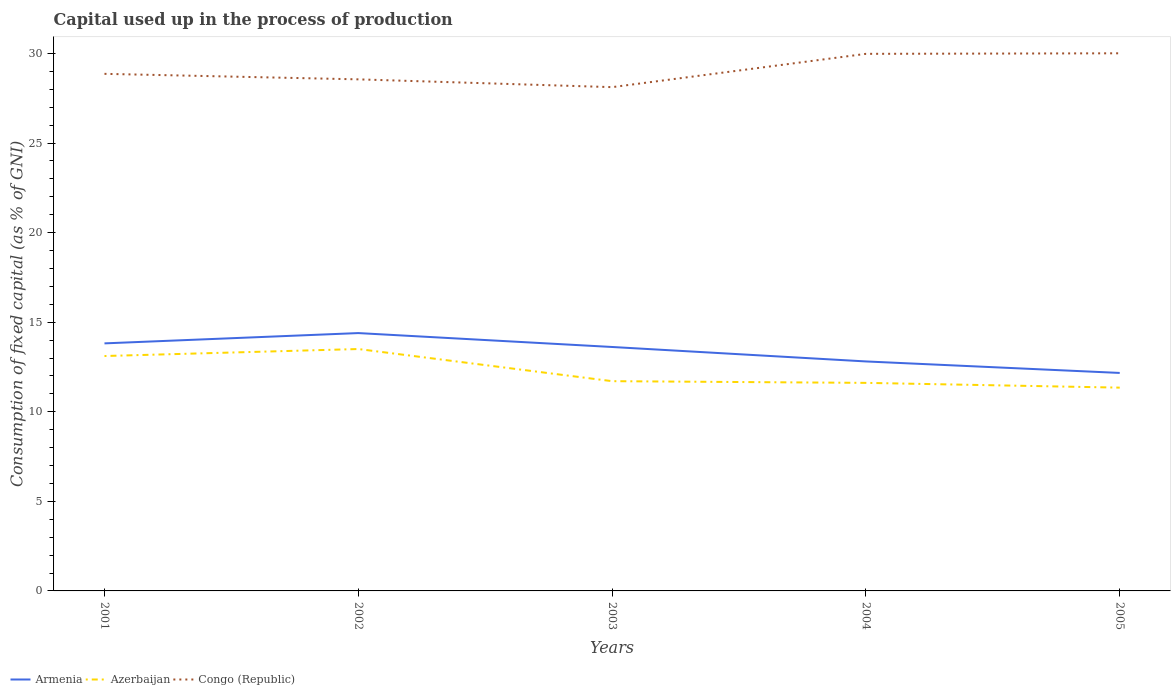How many different coloured lines are there?
Your answer should be very brief. 3. Does the line corresponding to Azerbaijan intersect with the line corresponding to Armenia?
Offer a terse response. No. Is the number of lines equal to the number of legend labels?
Your answer should be very brief. Yes. Across all years, what is the maximum capital used up in the process of production in Azerbaijan?
Provide a short and direct response. 11.35. What is the total capital used up in the process of production in Congo (Republic) in the graph?
Your answer should be very brief. -1.42. What is the difference between the highest and the second highest capital used up in the process of production in Congo (Republic)?
Give a very brief answer. 1.89. How many years are there in the graph?
Give a very brief answer. 5. Where does the legend appear in the graph?
Provide a short and direct response. Bottom left. How many legend labels are there?
Ensure brevity in your answer.  3. How are the legend labels stacked?
Your response must be concise. Horizontal. What is the title of the graph?
Offer a very short reply. Capital used up in the process of production. What is the label or title of the X-axis?
Provide a succinct answer. Years. What is the label or title of the Y-axis?
Ensure brevity in your answer.  Consumption of fixed capital (as % of GNI). What is the Consumption of fixed capital (as % of GNI) of Armenia in 2001?
Offer a terse response. 13.82. What is the Consumption of fixed capital (as % of GNI) in Azerbaijan in 2001?
Give a very brief answer. 13.11. What is the Consumption of fixed capital (as % of GNI) in Congo (Republic) in 2001?
Make the answer very short. 28.86. What is the Consumption of fixed capital (as % of GNI) of Armenia in 2002?
Your answer should be compact. 14.39. What is the Consumption of fixed capital (as % of GNI) in Azerbaijan in 2002?
Offer a terse response. 13.5. What is the Consumption of fixed capital (as % of GNI) of Congo (Republic) in 2002?
Keep it short and to the point. 28.55. What is the Consumption of fixed capital (as % of GNI) in Armenia in 2003?
Your answer should be compact. 13.62. What is the Consumption of fixed capital (as % of GNI) of Azerbaijan in 2003?
Your answer should be very brief. 11.71. What is the Consumption of fixed capital (as % of GNI) in Congo (Republic) in 2003?
Give a very brief answer. 28.12. What is the Consumption of fixed capital (as % of GNI) of Armenia in 2004?
Make the answer very short. 12.81. What is the Consumption of fixed capital (as % of GNI) in Azerbaijan in 2004?
Your response must be concise. 11.61. What is the Consumption of fixed capital (as % of GNI) in Congo (Republic) in 2004?
Your response must be concise. 29.98. What is the Consumption of fixed capital (as % of GNI) of Armenia in 2005?
Make the answer very short. 12.17. What is the Consumption of fixed capital (as % of GNI) in Azerbaijan in 2005?
Make the answer very short. 11.35. What is the Consumption of fixed capital (as % of GNI) of Congo (Republic) in 2005?
Offer a terse response. 30.01. Across all years, what is the maximum Consumption of fixed capital (as % of GNI) in Armenia?
Your response must be concise. 14.39. Across all years, what is the maximum Consumption of fixed capital (as % of GNI) in Azerbaijan?
Provide a succinct answer. 13.5. Across all years, what is the maximum Consumption of fixed capital (as % of GNI) of Congo (Republic)?
Provide a short and direct response. 30.01. Across all years, what is the minimum Consumption of fixed capital (as % of GNI) in Armenia?
Your response must be concise. 12.17. Across all years, what is the minimum Consumption of fixed capital (as % of GNI) in Azerbaijan?
Offer a terse response. 11.35. Across all years, what is the minimum Consumption of fixed capital (as % of GNI) of Congo (Republic)?
Keep it short and to the point. 28.12. What is the total Consumption of fixed capital (as % of GNI) in Armenia in the graph?
Your response must be concise. 66.8. What is the total Consumption of fixed capital (as % of GNI) of Azerbaijan in the graph?
Offer a very short reply. 61.28. What is the total Consumption of fixed capital (as % of GNI) of Congo (Republic) in the graph?
Keep it short and to the point. 145.52. What is the difference between the Consumption of fixed capital (as % of GNI) of Armenia in 2001 and that in 2002?
Offer a very short reply. -0.58. What is the difference between the Consumption of fixed capital (as % of GNI) in Azerbaijan in 2001 and that in 2002?
Provide a succinct answer. -0.39. What is the difference between the Consumption of fixed capital (as % of GNI) of Congo (Republic) in 2001 and that in 2002?
Your answer should be compact. 0.31. What is the difference between the Consumption of fixed capital (as % of GNI) in Armenia in 2001 and that in 2003?
Your answer should be compact. 0.2. What is the difference between the Consumption of fixed capital (as % of GNI) of Azerbaijan in 2001 and that in 2003?
Keep it short and to the point. 1.4. What is the difference between the Consumption of fixed capital (as % of GNI) in Congo (Republic) in 2001 and that in 2003?
Make the answer very short. 0.74. What is the difference between the Consumption of fixed capital (as % of GNI) of Armenia in 2001 and that in 2004?
Ensure brevity in your answer.  1.01. What is the difference between the Consumption of fixed capital (as % of GNI) in Azerbaijan in 2001 and that in 2004?
Give a very brief answer. 1.5. What is the difference between the Consumption of fixed capital (as % of GNI) of Congo (Republic) in 2001 and that in 2004?
Offer a terse response. -1.12. What is the difference between the Consumption of fixed capital (as % of GNI) in Armenia in 2001 and that in 2005?
Offer a very short reply. 1.65. What is the difference between the Consumption of fixed capital (as % of GNI) in Azerbaijan in 2001 and that in 2005?
Your answer should be compact. 1.76. What is the difference between the Consumption of fixed capital (as % of GNI) of Congo (Republic) in 2001 and that in 2005?
Your answer should be very brief. -1.15. What is the difference between the Consumption of fixed capital (as % of GNI) of Armenia in 2002 and that in 2003?
Offer a very short reply. 0.78. What is the difference between the Consumption of fixed capital (as % of GNI) in Azerbaijan in 2002 and that in 2003?
Ensure brevity in your answer.  1.79. What is the difference between the Consumption of fixed capital (as % of GNI) in Congo (Republic) in 2002 and that in 2003?
Provide a succinct answer. 0.43. What is the difference between the Consumption of fixed capital (as % of GNI) in Armenia in 2002 and that in 2004?
Make the answer very short. 1.58. What is the difference between the Consumption of fixed capital (as % of GNI) of Azerbaijan in 2002 and that in 2004?
Your answer should be compact. 1.89. What is the difference between the Consumption of fixed capital (as % of GNI) in Congo (Republic) in 2002 and that in 2004?
Offer a terse response. -1.42. What is the difference between the Consumption of fixed capital (as % of GNI) in Armenia in 2002 and that in 2005?
Your response must be concise. 2.23. What is the difference between the Consumption of fixed capital (as % of GNI) of Azerbaijan in 2002 and that in 2005?
Provide a short and direct response. 2.15. What is the difference between the Consumption of fixed capital (as % of GNI) in Congo (Republic) in 2002 and that in 2005?
Give a very brief answer. -1.45. What is the difference between the Consumption of fixed capital (as % of GNI) of Armenia in 2003 and that in 2004?
Make the answer very short. 0.81. What is the difference between the Consumption of fixed capital (as % of GNI) in Azerbaijan in 2003 and that in 2004?
Offer a terse response. 0.09. What is the difference between the Consumption of fixed capital (as % of GNI) in Congo (Republic) in 2003 and that in 2004?
Offer a very short reply. -1.86. What is the difference between the Consumption of fixed capital (as % of GNI) in Armenia in 2003 and that in 2005?
Your answer should be very brief. 1.45. What is the difference between the Consumption of fixed capital (as % of GNI) of Azerbaijan in 2003 and that in 2005?
Offer a very short reply. 0.36. What is the difference between the Consumption of fixed capital (as % of GNI) of Congo (Republic) in 2003 and that in 2005?
Offer a terse response. -1.89. What is the difference between the Consumption of fixed capital (as % of GNI) of Armenia in 2004 and that in 2005?
Your answer should be very brief. 0.64. What is the difference between the Consumption of fixed capital (as % of GNI) of Azerbaijan in 2004 and that in 2005?
Your answer should be compact. 0.27. What is the difference between the Consumption of fixed capital (as % of GNI) of Congo (Republic) in 2004 and that in 2005?
Your answer should be compact. -0.03. What is the difference between the Consumption of fixed capital (as % of GNI) in Armenia in 2001 and the Consumption of fixed capital (as % of GNI) in Azerbaijan in 2002?
Provide a succinct answer. 0.32. What is the difference between the Consumption of fixed capital (as % of GNI) in Armenia in 2001 and the Consumption of fixed capital (as % of GNI) in Congo (Republic) in 2002?
Offer a terse response. -14.74. What is the difference between the Consumption of fixed capital (as % of GNI) of Azerbaijan in 2001 and the Consumption of fixed capital (as % of GNI) of Congo (Republic) in 2002?
Give a very brief answer. -15.44. What is the difference between the Consumption of fixed capital (as % of GNI) of Armenia in 2001 and the Consumption of fixed capital (as % of GNI) of Azerbaijan in 2003?
Your answer should be compact. 2.11. What is the difference between the Consumption of fixed capital (as % of GNI) of Armenia in 2001 and the Consumption of fixed capital (as % of GNI) of Congo (Republic) in 2003?
Provide a short and direct response. -14.3. What is the difference between the Consumption of fixed capital (as % of GNI) of Azerbaijan in 2001 and the Consumption of fixed capital (as % of GNI) of Congo (Republic) in 2003?
Provide a succinct answer. -15.01. What is the difference between the Consumption of fixed capital (as % of GNI) in Armenia in 2001 and the Consumption of fixed capital (as % of GNI) in Azerbaijan in 2004?
Provide a succinct answer. 2.2. What is the difference between the Consumption of fixed capital (as % of GNI) in Armenia in 2001 and the Consumption of fixed capital (as % of GNI) in Congo (Republic) in 2004?
Offer a terse response. -16.16. What is the difference between the Consumption of fixed capital (as % of GNI) of Azerbaijan in 2001 and the Consumption of fixed capital (as % of GNI) of Congo (Republic) in 2004?
Offer a terse response. -16.87. What is the difference between the Consumption of fixed capital (as % of GNI) of Armenia in 2001 and the Consumption of fixed capital (as % of GNI) of Azerbaijan in 2005?
Provide a short and direct response. 2.47. What is the difference between the Consumption of fixed capital (as % of GNI) of Armenia in 2001 and the Consumption of fixed capital (as % of GNI) of Congo (Republic) in 2005?
Provide a short and direct response. -16.19. What is the difference between the Consumption of fixed capital (as % of GNI) of Azerbaijan in 2001 and the Consumption of fixed capital (as % of GNI) of Congo (Republic) in 2005?
Provide a short and direct response. -16.9. What is the difference between the Consumption of fixed capital (as % of GNI) in Armenia in 2002 and the Consumption of fixed capital (as % of GNI) in Azerbaijan in 2003?
Your answer should be very brief. 2.68. What is the difference between the Consumption of fixed capital (as % of GNI) of Armenia in 2002 and the Consumption of fixed capital (as % of GNI) of Congo (Republic) in 2003?
Offer a very short reply. -13.73. What is the difference between the Consumption of fixed capital (as % of GNI) of Azerbaijan in 2002 and the Consumption of fixed capital (as % of GNI) of Congo (Republic) in 2003?
Offer a terse response. -14.62. What is the difference between the Consumption of fixed capital (as % of GNI) in Armenia in 2002 and the Consumption of fixed capital (as % of GNI) in Azerbaijan in 2004?
Make the answer very short. 2.78. What is the difference between the Consumption of fixed capital (as % of GNI) in Armenia in 2002 and the Consumption of fixed capital (as % of GNI) in Congo (Republic) in 2004?
Provide a succinct answer. -15.59. What is the difference between the Consumption of fixed capital (as % of GNI) of Azerbaijan in 2002 and the Consumption of fixed capital (as % of GNI) of Congo (Republic) in 2004?
Offer a terse response. -16.48. What is the difference between the Consumption of fixed capital (as % of GNI) of Armenia in 2002 and the Consumption of fixed capital (as % of GNI) of Azerbaijan in 2005?
Provide a succinct answer. 3.05. What is the difference between the Consumption of fixed capital (as % of GNI) in Armenia in 2002 and the Consumption of fixed capital (as % of GNI) in Congo (Republic) in 2005?
Your response must be concise. -15.62. What is the difference between the Consumption of fixed capital (as % of GNI) in Azerbaijan in 2002 and the Consumption of fixed capital (as % of GNI) in Congo (Republic) in 2005?
Provide a succinct answer. -16.51. What is the difference between the Consumption of fixed capital (as % of GNI) of Armenia in 2003 and the Consumption of fixed capital (as % of GNI) of Azerbaijan in 2004?
Make the answer very short. 2. What is the difference between the Consumption of fixed capital (as % of GNI) in Armenia in 2003 and the Consumption of fixed capital (as % of GNI) in Congo (Republic) in 2004?
Give a very brief answer. -16.36. What is the difference between the Consumption of fixed capital (as % of GNI) in Azerbaijan in 2003 and the Consumption of fixed capital (as % of GNI) in Congo (Republic) in 2004?
Provide a short and direct response. -18.27. What is the difference between the Consumption of fixed capital (as % of GNI) of Armenia in 2003 and the Consumption of fixed capital (as % of GNI) of Azerbaijan in 2005?
Offer a very short reply. 2.27. What is the difference between the Consumption of fixed capital (as % of GNI) in Armenia in 2003 and the Consumption of fixed capital (as % of GNI) in Congo (Republic) in 2005?
Your answer should be compact. -16.39. What is the difference between the Consumption of fixed capital (as % of GNI) in Azerbaijan in 2003 and the Consumption of fixed capital (as % of GNI) in Congo (Republic) in 2005?
Your response must be concise. -18.3. What is the difference between the Consumption of fixed capital (as % of GNI) of Armenia in 2004 and the Consumption of fixed capital (as % of GNI) of Azerbaijan in 2005?
Keep it short and to the point. 1.46. What is the difference between the Consumption of fixed capital (as % of GNI) of Armenia in 2004 and the Consumption of fixed capital (as % of GNI) of Congo (Republic) in 2005?
Your response must be concise. -17.2. What is the difference between the Consumption of fixed capital (as % of GNI) of Azerbaijan in 2004 and the Consumption of fixed capital (as % of GNI) of Congo (Republic) in 2005?
Your answer should be compact. -18.4. What is the average Consumption of fixed capital (as % of GNI) in Armenia per year?
Make the answer very short. 13.36. What is the average Consumption of fixed capital (as % of GNI) of Azerbaijan per year?
Your answer should be very brief. 12.26. What is the average Consumption of fixed capital (as % of GNI) of Congo (Republic) per year?
Keep it short and to the point. 29.1. In the year 2001, what is the difference between the Consumption of fixed capital (as % of GNI) of Armenia and Consumption of fixed capital (as % of GNI) of Azerbaijan?
Your response must be concise. 0.71. In the year 2001, what is the difference between the Consumption of fixed capital (as % of GNI) in Armenia and Consumption of fixed capital (as % of GNI) in Congo (Republic)?
Give a very brief answer. -15.05. In the year 2001, what is the difference between the Consumption of fixed capital (as % of GNI) of Azerbaijan and Consumption of fixed capital (as % of GNI) of Congo (Republic)?
Your answer should be compact. -15.75. In the year 2002, what is the difference between the Consumption of fixed capital (as % of GNI) in Armenia and Consumption of fixed capital (as % of GNI) in Azerbaijan?
Offer a very short reply. 0.89. In the year 2002, what is the difference between the Consumption of fixed capital (as % of GNI) of Armenia and Consumption of fixed capital (as % of GNI) of Congo (Republic)?
Offer a very short reply. -14.16. In the year 2002, what is the difference between the Consumption of fixed capital (as % of GNI) in Azerbaijan and Consumption of fixed capital (as % of GNI) in Congo (Republic)?
Provide a short and direct response. -15.05. In the year 2003, what is the difference between the Consumption of fixed capital (as % of GNI) in Armenia and Consumption of fixed capital (as % of GNI) in Azerbaijan?
Provide a short and direct response. 1.91. In the year 2003, what is the difference between the Consumption of fixed capital (as % of GNI) in Armenia and Consumption of fixed capital (as % of GNI) in Congo (Republic)?
Give a very brief answer. -14.5. In the year 2003, what is the difference between the Consumption of fixed capital (as % of GNI) of Azerbaijan and Consumption of fixed capital (as % of GNI) of Congo (Republic)?
Your response must be concise. -16.41. In the year 2004, what is the difference between the Consumption of fixed capital (as % of GNI) in Armenia and Consumption of fixed capital (as % of GNI) in Azerbaijan?
Keep it short and to the point. 1.2. In the year 2004, what is the difference between the Consumption of fixed capital (as % of GNI) of Armenia and Consumption of fixed capital (as % of GNI) of Congo (Republic)?
Provide a succinct answer. -17.17. In the year 2004, what is the difference between the Consumption of fixed capital (as % of GNI) in Azerbaijan and Consumption of fixed capital (as % of GNI) in Congo (Republic)?
Offer a very short reply. -18.37. In the year 2005, what is the difference between the Consumption of fixed capital (as % of GNI) of Armenia and Consumption of fixed capital (as % of GNI) of Azerbaijan?
Provide a short and direct response. 0.82. In the year 2005, what is the difference between the Consumption of fixed capital (as % of GNI) in Armenia and Consumption of fixed capital (as % of GNI) in Congo (Republic)?
Offer a terse response. -17.84. In the year 2005, what is the difference between the Consumption of fixed capital (as % of GNI) in Azerbaijan and Consumption of fixed capital (as % of GNI) in Congo (Republic)?
Offer a terse response. -18.66. What is the ratio of the Consumption of fixed capital (as % of GNI) in Armenia in 2001 to that in 2002?
Provide a short and direct response. 0.96. What is the ratio of the Consumption of fixed capital (as % of GNI) in Azerbaijan in 2001 to that in 2002?
Provide a short and direct response. 0.97. What is the ratio of the Consumption of fixed capital (as % of GNI) in Congo (Republic) in 2001 to that in 2002?
Keep it short and to the point. 1.01. What is the ratio of the Consumption of fixed capital (as % of GNI) in Armenia in 2001 to that in 2003?
Your answer should be compact. 1.01. What is the ratio of the Consumption of fixed capital (as % of GNI) in Azerbaijan in 2001 to that in 2003?
Your answer should be compact. 1.12. What is the ratio of the Consumption of fixed capital (as % of GNI) of Congo (Republic) in 2001 to that in 2003?
Ensure brevity in your answer.  1.03. What is the ratio of the Consumption of fixed capital (as % of GNI) of Armenia in 2001 to that in 2004?
Ensure brevity in your answer.  1.08. What is the ratio of the Consumption of fixed capital (as % of GNI) of Azerbaijan in 2001 to that in 2004?
Make the answer very short. 1.13. What is the ratio of the Consumption of fixed capital (as % of GNI) of Congo (Republic) in 2001 to that in 2004?
Provide a short and direct response. 0.96. What is the ratio of the Consumption of fixed capital (as % of GNI) of Armenia in 2001 to that in 2005?
Provide a short and direct response. 1.14. What is the ratio of the Consumption of fixed capital (as % of GNI) of Azerbaijan in 2001 to that in 2005?
Your answer should be very brief. 1.16. What is the ratio of the Consumption of fixed capital (as % of GNI) in Congo (Republic) in 2001 to that in 2005?
Provide a short and direct response. 0.96. What is the ratio of the Consumption of fixed capital (as % of GNI) of Armenia in 2002 to that in 2003?
Offer a terse response. 1.06. What is the ratio of the Consumption of fixed capital (as % of GNI) in Azerbaijan in 2002 to that in 2003?
Provide a succinct answer. 1.15. What is the ratio of the Consumption of fixed capital (as % of GNI) in Congo (Republic) in 2002 to that in 2003?
Your answer should be very brief. 1.02. What is the ratio of the Consumption of fixed capital (as % of GNI) of Armenia in 2002 to that in 2004?
Offer a terse response. 1.12. What is the ratio of the Consumption of fixed capital (as % of GNI) in Azerbaijan in 2002 to that in 2004?
Offer a terse response. 1.16. What is the ratio of the Consumption of fixed capital (as % of GNI) of Congo (Republic) in 2002 to that in 2004?
Provide a short and direct response. 0.95. What is the ratio of the Consumption of fixed capital (as % of GNI) in Armenia in 2002 to that in 2005?
Provide a short and direct response. 1.18. What is the ratio of the Consumption of fixed capital (as % of GNI) of Azerbaijan in 2002 to that in 2005?
Offer a very short reply. 1.19. What is the ratio of the Consumption of fixed capital (as % of GNI) of Congo (Republic) in 2002 to that in 2005?
Your answer should be very brief. 0.95. What is the ratio of the Consumption of fixed capital (as % of GNI) in Armenia in 2003 to that in 2004?
Give a very brief answer. 1.06. What is the ratio of the Consumption of fixed capital (as % of GNI) of Azerbaijan in 2003 to that in 2004?
Give a very brief answer. 1.01. What is the ratio of the Consumption of fixed capital (as % of GNI) of Congo (Republic) in 2003 to that in 2004?
Keep it short and to the point. 0.94. What is the ratio of the Consumption of fixed capital (as % of GNI) of Armenia in 2003 to that in 2005?
Offer a very short reply. 1.12. What is the ratio of the Consumption of fixed capital (as % of GNI) of Azerbaijan in 2003 to that in 2005?
Give a very brief answer. 1.03. What is the ratio of the Consumption of fixed capital (as % of GNI) in Congo (Republic) in 2003 to that in 2005?
Make the answer very short. 0.94. What is the ratio of the Consumption of fixed capital (as % of GNI) of Armenia in 2004 to that in 2005?
Make the answer very short. 1.05. What is the ratio of the Consumption of fixed capital (as % of GNI) of Azerbaijan in 2004 to that in 2005?
Offer a terse response. 1.02. What is the ratio of the Consumption of fixed capital (as % of GNI) in Congo (Republic) in 2004 to that in 2005?
Provide a succinct answer. 1. What is the difference between the highest and the second highest Consumption of fixed capital (as % of GNI) of Armenia?
Your response must be concise. 0.58. What is the difference between the highest and the second highest Consumption of fixed capital (as % of GNI) in Azerbaijan?
Offer a terse response. 0.39. What is the difference between the highest and the second highest Consumption of fixed capital (as % of GNI) of Congo (Republic)?
Provide a short and direct response. 0.03. What is the difference between the highest and the lowest Consumption of fixed capital (as % of GNI) in Armenia?
Make the answer very short. 2.23. What is the difference between the highest and the lowest Consumption of fixed capital (as % of GNI) of Azerbaijan?
Provide a short and direct response. 2.15. What is the difference between the highest and the lowest Consumption of fixed capital (as % of GNI) of Congo (Republic)?
Offer a terse response. 1.89. 